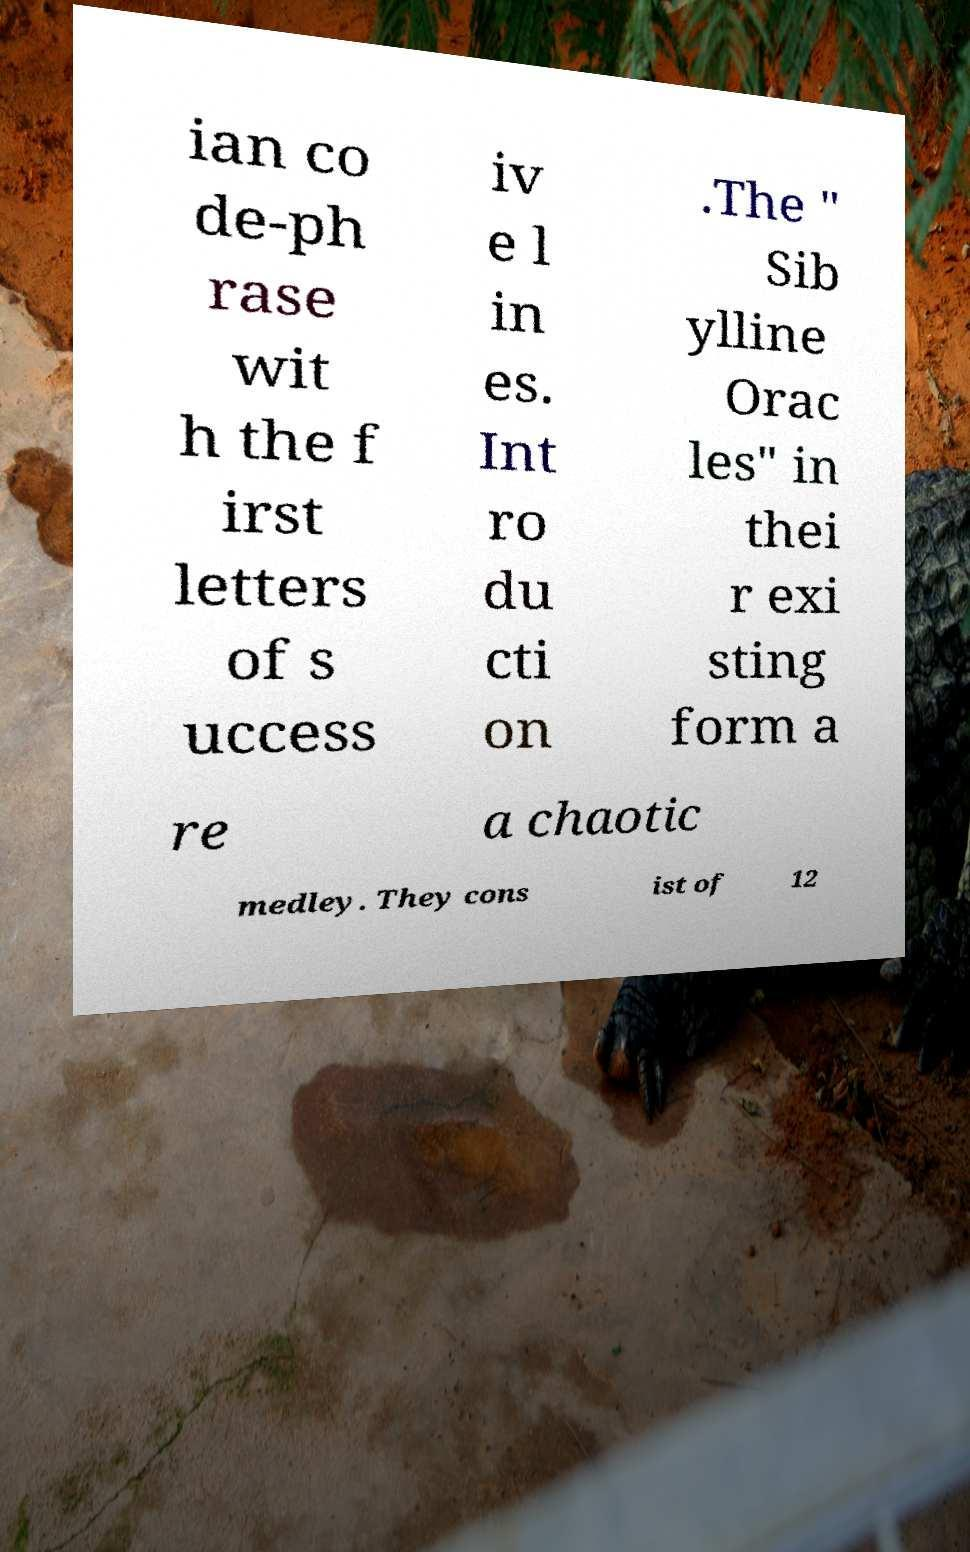Please identify and transcribe the text found in this image. ian co de-ph rase wit h the f irst letters of s uccess iv e l in es. Int ro du cti on .The " Sib ylline Orac les" in thei r exi sting form a re a chaotic medley. They cons ist of 12 